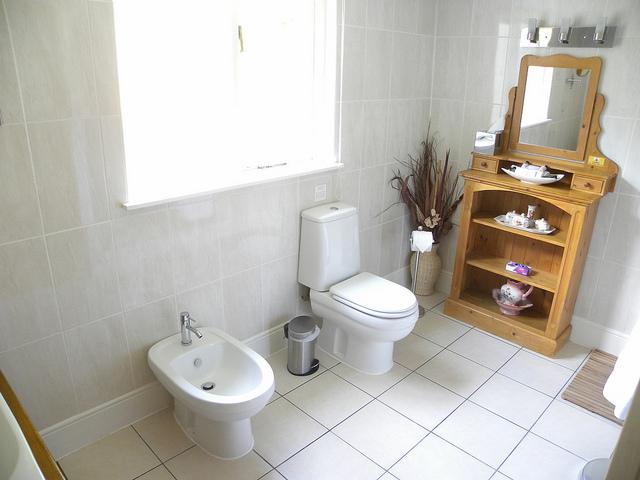Is the toilet lid down?
Quick response, please. Yes. Does the trash can have a liner?
Keep it brief. Yes. What country is this in?
Give a very brief answer. France. 